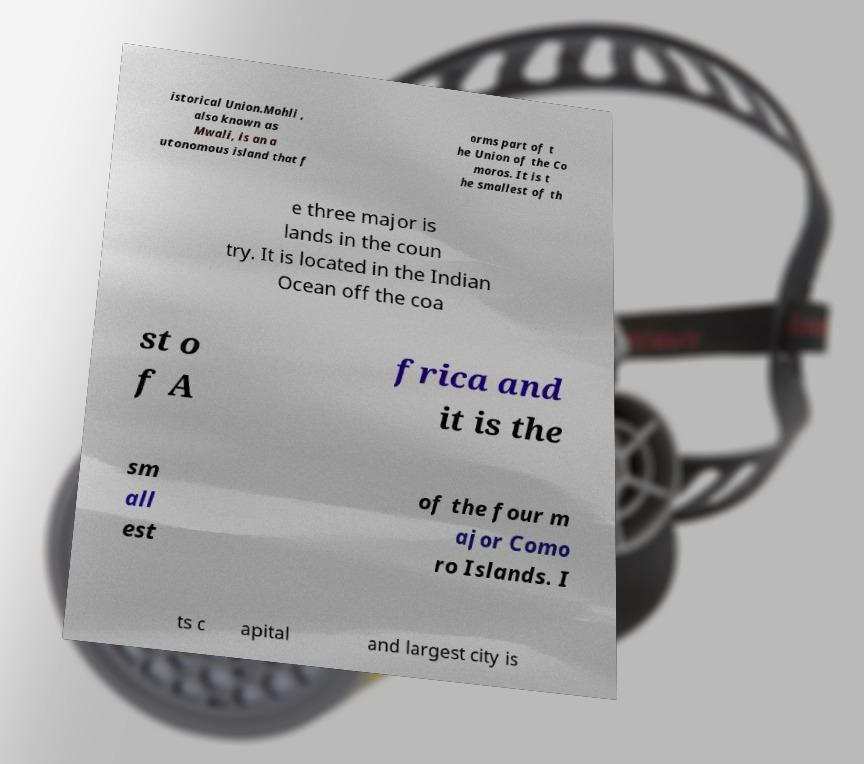Could you extract and type out the text from this image? istorical Union.Mohli , also known as Mwali, is an a utonomous island that f orms part of t he Union of the Co moros. It is t he smallest of th e three major is lands in the coun try. It is located in the Indian Ocean off the coa st o f A frica and it is the sm all est of the four m ajor Como ro Islands. I ts c apital and largest city is 